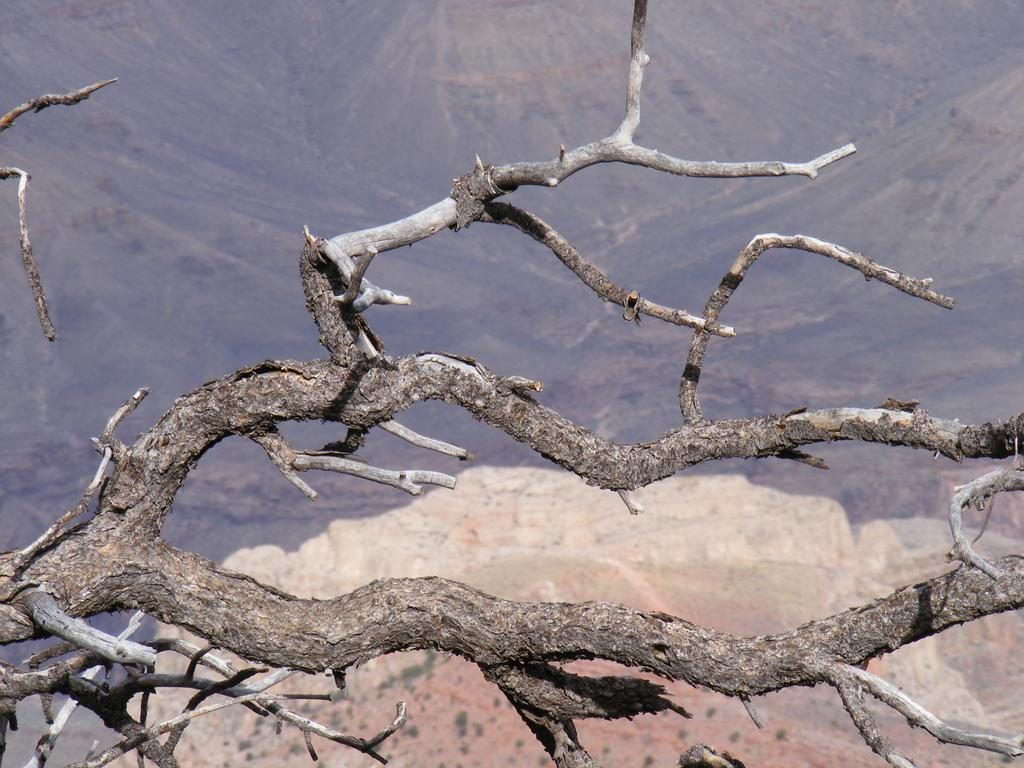What is the main subject in the foreground of the image? The main subject in the foreground of the image is the branches of a tree. Where are the branches located in relation to the image? The branches are in the front of the image. What type of vegetation can be seen in the background of the image? There is grass in the far distance in the background of the image. What else can be found on the ground in the image? There are plants on the ground in the image. What type of powder is sprinkled on the branches in the image? There is no powder visible on the branches in the image. 